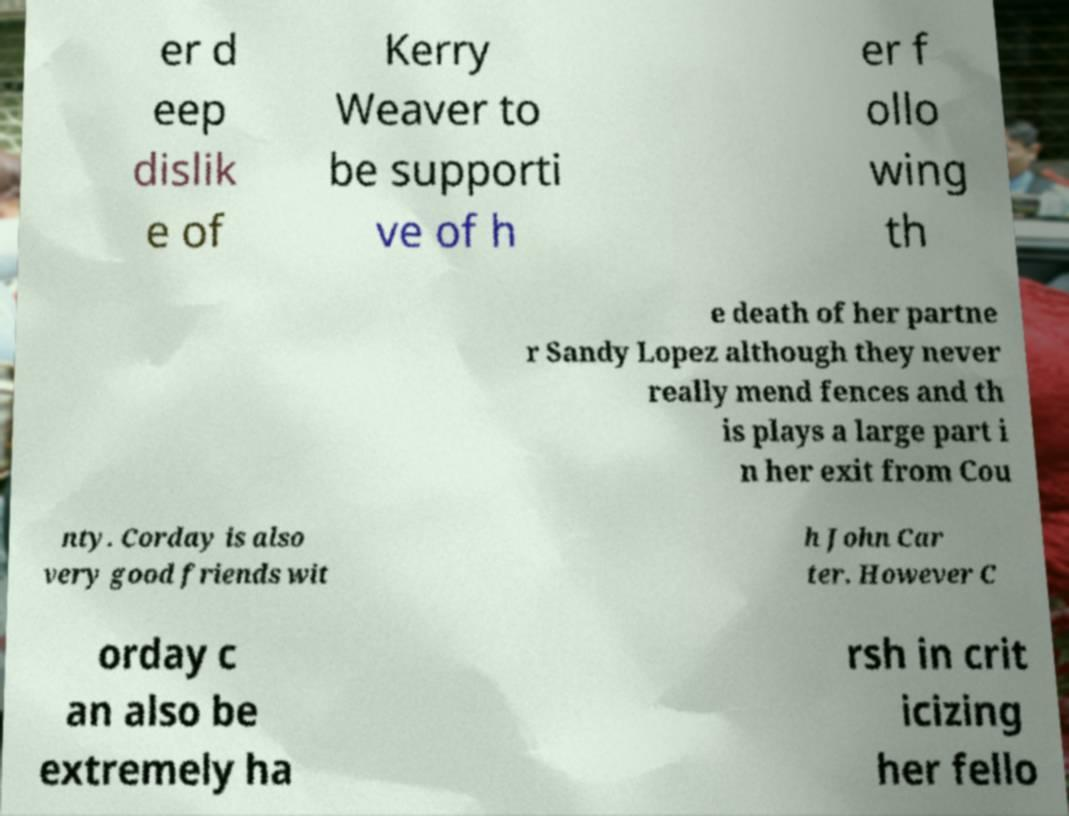I need the written content from this picture converted into text. Can you do that? er d eep dislik e of Kerry Weaver to be supporti ve of h er f ollo wing th e death of her partne r Sandy Lopez although they never really mend fences and th is plays a large part i n her exit from Cou nty. Corday is also very good friends wit h John Car ter. However C orday c an also be extremely ha rsh in crit icizing her fello 